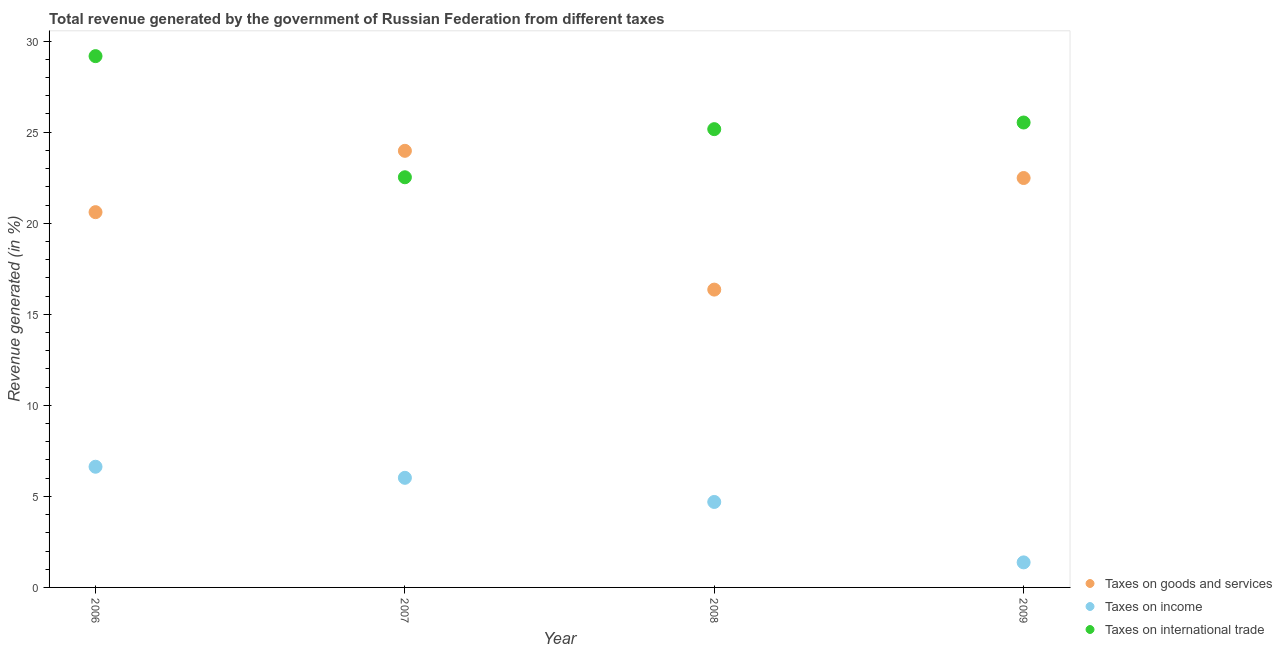How many different coloured dotlines are there?
Offer a terse response. 3. Is the number of dotlines equal to the number of legend labels?
Your response must be concise. Yes. What is the percentage of revenue generated by taxes on income in 2006?
Your answer should be compact. 6.63. Across all years, what is the maximum percentage of revenue generated by tax on international trade?
Make the answer very short. 29.18. Across all years, what is the minimum percentage of revenue generated by taxes on goods and services?
Make the answer very short. 16.35. What is the total percentage of revenue generated by taxes on goods and services in the graph?
Your answer should be very brief. 83.42. What is the difference between the percentage of revenue generated by taxes on goods and services in 2007 and that in 2008?
Your answer should be compact. 7.62. What is the difference between the percentage of revenue generated by taxes on goods and services in 2007 and the percentage of revenue generated by tax on international trade in 2008?
Ensure brevity in your answer.  -1.19. What is the average percentage of revenue generated by taxes on income per year?
Your response must be concise. 4.68. In the year 2009, what is the difference between the percentage of revenue generated by taxes on goods and services and percentage of revenue generated by taxes on income?
Provide a succinct answer. 21.11. What is the ratio of the percentage of revenue generated by tax on international trade in 2007 to that in 2009?
Your response must be concise. 0.88. Is the difference between the percentage of revenue generated by taxes on goods and services in 2006 and 2007 greater than the difference between the percentage of revenue generated by tax on international trade in 2006 and 2007?
Ensure brevity in your answer.  No. What is the difference between the highest and the second highest percentage of revenue generated by taxes on goods and services?
Give a very brief answer. 1.49. What is the difference between the highest and the lowest percentage of revenue generated by taxes on income?
Give a very brief answer. 5.25. In how many years, is the percentage of revenue generated by taxes on income greater than the average percentage of revenue generated by taxes on income taken over all years?
Offer a terse response. 3. Is the sum of the percentage of revenue generated by taxes on income in 2007 and 2008 greater than the maximum percentage of revenue generated by tax on international trade across all years?
Give a very brief answer. No. Is it the case that in every year, the sum of the percentage of revenue generated by taxes on goods and services and percentage of revenue generated by taxes on income is greater than the percentage of revenue generated by tax on international trade?
Your answer should be very brief. No. Does the percentage of revenue generated by taxes on goods and services monotonically increase over the years?
Keep it short and to the point. No. Is the percentage of revenue generated by tax on international trade strictly less than the percentage of revenue generated by taxes on goods and services over the years?
Provide a succinct answer. No. How many dotlines are there?
Make the answer very short. 3. How many years are there in the graph?
Offer a terse response. 4. Does the graph contain any zero values?
Your answer should be very brief. No. Does the graph contain grids?
Offer a terse response. No. Where does the legend appear in the graph?
Your response must be concise. Bottom right. How many legend labels are there?
Offer a very short reply. 3. How are the legend labels stacked?
Ensure brevity in your answer.  Vertical. What is the title of the graph?
Provide a short and direct response. Total revenue generated by the government of Russian Federation from different taxes. What is the label or title of the Y-axis?
Provide a succinct answer. Revenue generated (in %). What is the Revenue generated (in %) in Taxes on goods and services in 2006?
Provide a short and direct response. 20.61. What is the Revenue generated (in %) in Taxes on income in 2006?
Your answer should be very brief. 6.63. What is the Revenue generated (in %) in Taxes on international trade in 2006?
Make the answer very short. 29.18. What is the Revenue generated (in %) in Taxes on goods and services in 2007?
Give a very brief answer. 23.98. What is the Revenue generated (in %) of Taxes on income in 2007?
Offer a very short reply. 6.02. What is the Revenue generated (in %) in Taxes on international trade in 2007?
Provide a short and direct response. 22.52. What is the Revenue generated (in %) in Taxes on goods and services in 2008?
Your response must be concise. 16.35. What is the Revenue generated (in %) of Taxes on income in 2008?
Your response must be concise. 4.69. What is the Revenue generated (in %) in Taxes on international trade in 2008?
Keep it short and to the point. 25.17. What is the Revenue generated (in %) in Taxes on goods and services in 2009?
Your response must be concise. 22.48. What is the Revenue generated (in %) of Taxes on income in 2009?
Offer a terse response. 1.38. What is the Revenue generated (in %) of Taxes on international trade in 2009?
Your answer should be compact. 25.53. Across all years, what is the maximum Revenue generated (in %) in Taxes on goods and services?
Make the answer very short. 23.98. Across all years, what is the maximum Revenue generated (in %) of Taxes on income?
Your answer should be compact. 6.63. Across all years, what is the maximum Revenue generated (in %) of Taxes on international trade?
Offer a very short reply. 29.18. Across all years, what is the minimum Revenue generated (in %) of Taxes on goods and services?
Your response must be concise. 16.35. Across all years, what is the minimum Revenue generated (in %) of Taxes on income?
Provide a succinct answer. 1.38. Across all years, what is the minimum Revenue generated (in %) in Taxes on international trade?
Provide a succinct answer. 22.52. What is the total Revenue generated (in %) of Taxes on goods and services in the graph?
Your response must be concise. 83.42. What is the total Revenue generated (in %) in Taxes on income in the graph?
Your answer should be compact. 18.71. What is the total Revenue generated (in %) in Taxes on international trade in the graph?
Give a very brief answer. 102.4. What is the difference between the Revenue generated (in %) of Taxes on goods and services in 2006 and that in 2007?
Keep it short and to the point. -3.37. What is the difference between the Revenue generated (in %) of Taxes on income in 2006 and that in 2007?
Give a very brief answer. 0.61. What is the difference between the Revenue generated (in %) of Taxes on international trade in 2006 and that in 2007?
Provide a succinct answer. 6.65. What is the difference between the Revenue generated (in %) in Taxes on goods and services in 2006 and that in 2008?
Offer a very short reply. 4.25. What is the difference between the Revenue generated (in %) in Taxes on income in 2006 and that in 2008?
Make the answer very short. 1.93. What is the difference between the Revenue generated (in %) of Taxes on international trade in 2006 and that in 2008?
Offer a very short reply. 4.01. What is the difference between the Revenue generated (in %) of Taxes on goods and services in 2006 and that in 2009?
Your answer should be compact. -1.87. What is the difference between the Revenue generated (in %) of Taxes on income in 2006 and that in 2009?
Provide a short and direct response. 5.25. What is the difference between the Revenue generated (in %) in Taxes on international trade in 2006 and that in 2009?
Give a very brief answer. 3.65. What is the difference between the Revenue generated (in %) of Taxes on goods and services in 2007 and that in 2008?
Provide a succinct answer. 7.62. What is the difference between the Revenue generated (in %) in Taxes on income in 2007 and that in 2008?
Offer a very short reply. 1.32. What is the difference between the Revenue generated (in %) in Taxes on international trade in 2007 and that in 2008?
Your answer should be compact. -2.64. What is the difference between the Revenue generated (in %) in Taxes on goods and services in 2007 and that in 2009?
Your response must be concise. 1.49. What is the difference between the Revenue generated (in %) of Taxes on income in 2007 and that in 2009?
Provide a short and direct response. 4.64. What is the difference between the Revenue generated (in %) of Taxes on international trade in 2007 and that in 2009?
Your response must be concise. -3.01. What is the difference between the Revenue generated (in %) in Taxes on goods and services in 2008 and that in 2009?
Ensure brevity in your answer.  -6.13. What is the difference between the Revenue generated (in %) of Taxes on income in 2008 and that in 2009?
Your answer should be very brief. 3.32. What is the difference between the Revenue generated (in %) of Taxes on international trade in 2008 and that in 2009?
Your answer should be very brief. -0.36. What is the difference between the Revenue generated (in %) of Taxes on goods and services in 2006 and the Revenue generated (in %) of Taxes on income in 2007?
Your answer should be compact. 14.59. What is the difference between the Revenue generated (in %) of Taxes on goods and services in 2006 and the Revenue generated (in %) of Taxes on international trade in 2007?
Ensure brevity in your answer.  -1.92. What is the difference between the Revenue generated (in %) of Taxes on income in 2006 and the Revenue generated (in %) of Taxes on international trade in 2007?
Your response must be concise. -15.9. What is the difference between the Revenue generated (in %) of Taxes on goods and services in 2006 and the Revenue generated (in %) of Taxes on income in 2008?
Provide a short and direct response. 15.91. What is the difference between the Revenue generated (in %) of Taxes on goods and services in 2006 and the Revenue generated (in %) of Taxes on international trade in 2008?
Offer a terse response. -4.56. What is the difference between the Revenue generated (in %) of Taxes on income in 2006 and the Revenue generated (in %) of Taxes on international trade in 2008?
Offer a terse response. -18.54. What is the difference between the Revenue generated (in %) in Taxes on goods and services in 2006 and the Revenue generated (in %) in Taxes on income in 2009?
Your answer should be very brief. 19.23. What is the difference between the Revenue generated (in %) of Taxes on goods and services in 2006 and the Revenue generated (in %) of Taxes on international trade in 2009?
Your answer should be very brief. -4.92. What is the difference between the Revenue generated (in %) of Taxes on income in 2006 and the Revenue generated (in %) of Taxes on international trade in 2009?
Offer a very short reply. -18.9. What is the difference between the Revenue generated (in %) of Taxes on goods and services in 2007 and the Revenue generated (in %) of Taxes on income in 2008?
Your answer should be very brief. 19.28. What is the difference between the Revenue generated (in %) in Taxes on goods and services in 2007 and the Revenue generated (in %) in Taxes on international trade in 2008?
Your answer should be compact. -1.19. What is the difference between the Revenue generated (in %) of Taxes on income in 2007 and the Revenue generated (in %) of Taxes on international trade in 2008?
Your answer should be very brief. -19.15. What is the difference between the Revenue generated (in %) in Taxes on goods and services in 2007 and the Revenue generated (in %) in Taxes on income in 2009?
Your answer should be very brief. 22.6. What is the difference between the Revenue generated (in %) in Taxes on goods and services in 2007 and the Revenue generated (in %) in Taxes on international trade in 2009?
Your response must be concise. -1.55. What is the difference between the Revenue generated (in %) in Taxes on income in 2007 and the Revenue generated (in %) in Taxes on international trade in 2009?
Ensure brevity in your answer.  -19.51. What is the difference between the Revenue generated (in %) of Taxes on goods and services in 2008 and the Revenue generated (in %) of Taxes on income in 2009?
Provide a short and direct response. 14.98. What is the difference between the Revenue generated (in %) in Taxes on goods and services in 2008 and the Revenue generated (in %) in Taxes on international trade in 2009?
Ensure brevity in your answer.  -9.18. What is the difference between the Revenue generated (in %) of Taxes on income in 2008 and the Revenue generated (in %) of Taxes on international trade in 2009?
Offer a very short reply. -20.84. What is the average Revenue generated (in %) in Taxes on goods and services per year?
Make the answer very short. 20.86. What is the average Revenue generated (in %) of Taxes on income per year?
Provide a short and direct response. 4.68. What is the average Revenue generated (in %) in Taxes on international trade per year?
Offer a terse response. 25.6. In the year 2006, what is the difference between the Revenue generated (in %) of Taxes on goods and services and Revenue generated (in %) of Taxes on income?
Your answer should be compact. 13.98. In the year 2006, what is the difference between the Revenue generated (in %) in Taxes on goods and services and Revenue generated (in %) in Taxes on international trade?
Make the answer very short. -8.57. In the year 2006, what is the difference between the Revenue generated (in %) in Taxes on income and Revenue generated (in %) in Taxes on international trade?
Give a very brief answer. -22.55. In the year 2007, what is the difference between the Revenue generated (in %) in Taxes on goods and services and Revenue generated (in %) in Taxes on income?
Your answer should be very brief. 17.96. In the year 2007, what is the difference between the Revenue generated (in %) of Taxes on goods and services and Revenue generated (in %) of Taxes on international trade?
Provide a succinct answer. 1.45. In the year 2007, what is the difference between the Revenue generated (in %) in Taxes on income and Revenue generated (in %) in Taxes on international trade?
Provide a succinct answer. -16.51. In the year 2008, what is the difference between the Revenue generated (in %) in Taxes on goods and services and Revenue generated (in %) in Taxes on income?
Your answer should be compact. 11.66. In the year 2008, what is the difference between the Revenue generated (in %) of Taxes on goods and services and Revenue generated (in %) of Taxes on international trade?
Provide a short and direct response. -8.81. In the year 2008, what is the difference between the Revenue generated (in %) in Taxes on income and Revenue generated (in %) in Taxes on international trade?
Your response must be concise. -20.47. In the year 2009, what is the difference between the Revenue generated (in %) in Taxes on goods and services and Revenue generated (in %) in Taxes on income?
Provide a succinct answer. 21.11. In the year 2009, what is the difference between the Revenue generated (in %) in Taxes on goods and services and Revenue generated (in %) in Taxes on international trade?
Provide a short and direct response. -3.05. In the year 2009, what is the difference between the Revenue generated (in %) in Taxes on income and Revenue generated (in %) in Taxes on international trade?
Give a very brief answer. -24.16. What is the ratio of the Revenue generated (in %) in Taxes on goods and services in 2006 to that in 2007?
Ensure brevity in your answer.  0.86. What is the ratio of the Revenue generated (in %) of Taxes on income in 2006 to that in 2007?
Your answer should be compact. 1.1. What is the ratio of the Revenue generated (in %) of Taxes on international trade in 2006 to that in 2007?
Make the answer very short. 1.3. What is the ratio of the Revenue generated (in %) of Taxes on goods and services in 2006 to that in 2008?
Give a very brief answer. 1.26. What is the ratio of the Revenue generated (in %) of Taxes on income in 2006 to that in 2008?
Provide a succinct answer. 1.41. What is the ratio of the Revenue generated (in %) in Taxes on international trade in 2006 to that in 2008?
Ensure brevity in your answer.  1.16. What is the ratio of the Revenue generated (in %) of Taxes on goods and services in 2006 to that in 2009?
Offer a very short reply. 0.92. What is the ratio of the Revenue generated (in %) of Taxes on income in 2006 to that in 2009?
Provide a succinct answer. 4.82. What is the ratio of the Revenue generated (in %) in Taxes on international trade in 2006 to that in 2009?
Your response must be concise. 1.14. What is the ratio of the Revenue generated (in %) of Taxes on goods and services in 2007 to that in 2008?
Your answer should be compact. 1.47. What is the ratio of the Revenue generated (in %) in Taxes on income in 2007 to that in 2008?
Offer a very short reply. 1.28. What is the ratio of the Revenue generated (in %) in Taxes on international trade in 2007 to that in 2008?
Provide a succinct answer. 0.9. What is the ratio of the Revenue generated (in %) in Taxes on goods and services in 2007 to that in 2009?
Provide a succinct answer. 1.07. What is the ratio of the Revenue generated (in %) in Taxes on income in 2007 to that in 2009?
Give a very brief answer. 4.38. What is the ratio of the Revenue generated (in %) of Taxes on international trade in 2007 to that in 2009?
Keep it short and to the point. 0.88. What is the ratio of the Revenue generated (in %) of Taxes on goods and services in 2008 to that in 2009?
Offer a terse response. 0.73. What is the ratio of the Revenue generated (in %) in Taxes on income in 2008 to that in 2009?
Keep it short and to the point. 3.41. What is the ratio of the Revenue generated (in %) in Taxes on international trade in 2008 to that in 2009?
Your response must be concise. 0.99. What is the difference between the highest and the second highest Revenue generated (in %) of Taxes on goods and services?
Your response must be concise. 1.49. What is the difference between the highest and the second highest Revenue generated (in %) in Taxes on income?
Give a very brief answer. 0.61. What is the difference between the highest and the second highest Revenue generated (in %) in Taxes on international trade?
Give a very brief answer. 3.65. What is the difference between the highest and the lowest Revenue generated (in %) in Taxes on goods and services?
Your answer should be compact. 7.62. What is the difference between the highest and the lowest Revenue generated (in %) of Taxes on income?
Keep it short and to the point. 5.25. What is the difference between the highest and the lowest Revenue generated (in %) in Taxes on international trade?
Give a very brief answer. 6.65. 